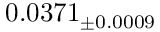Convert formula to latex. <formula><loc_0><loc_0><loc_500><loc_500>0 . 0 3 7 1 _ { \pm 0 . 0 0 0 9 }</formula> 